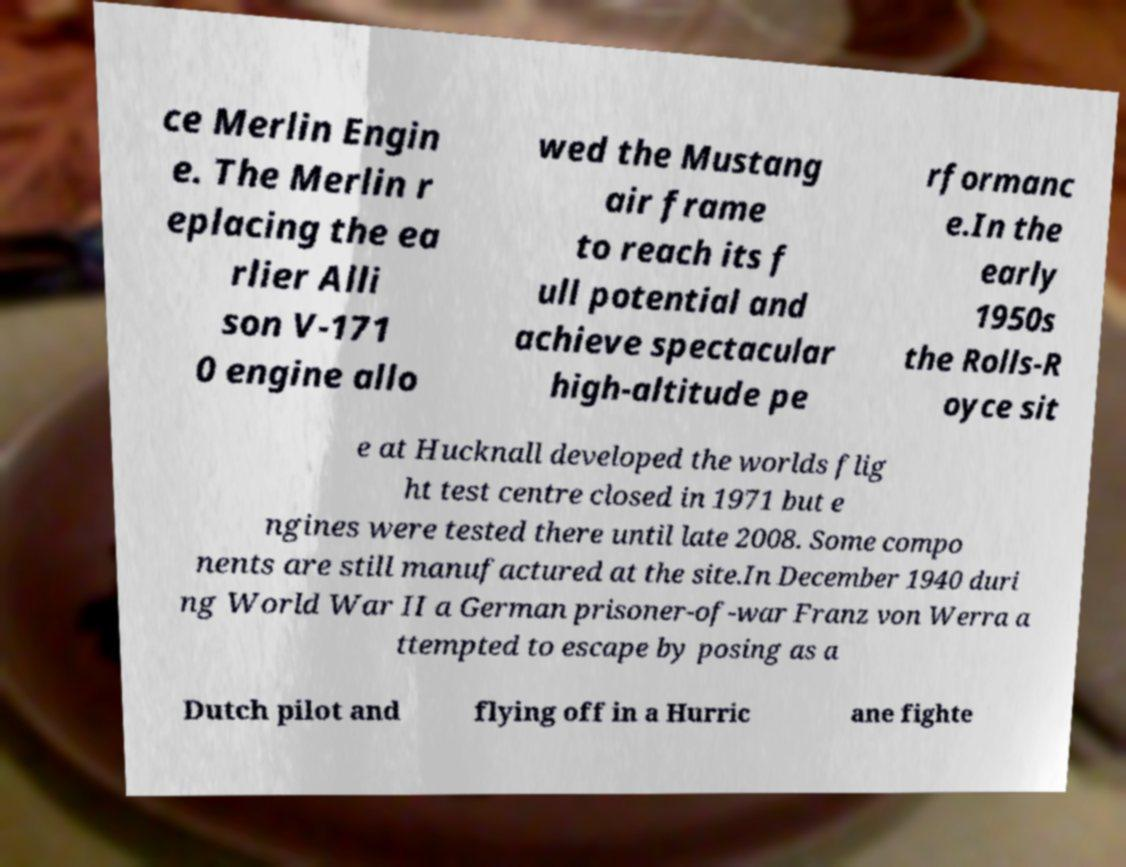Please read and relay the text visible in this image. What does it say? ce Merlin Engin e. The Merlin r eplacing the ea rlier Alli son V-171 0 engine allo wed the Mustang air frame to reach its f ull potential and achieve spectacular high-altitude pe rformanc e.In the early 1950s the Rolls-R oyce sit e at Hucknall developed the worlds flig ht test centre closed in 1971 but e ngines were tested there until late 2008. Some compo nents are still manufactured at the site.In December 1940 duri ng World War II a German prisoner-of-war Franz von Werra a ttempted to escape by posing as a Dutch pilot and flying off in a Hurric ane fighte 